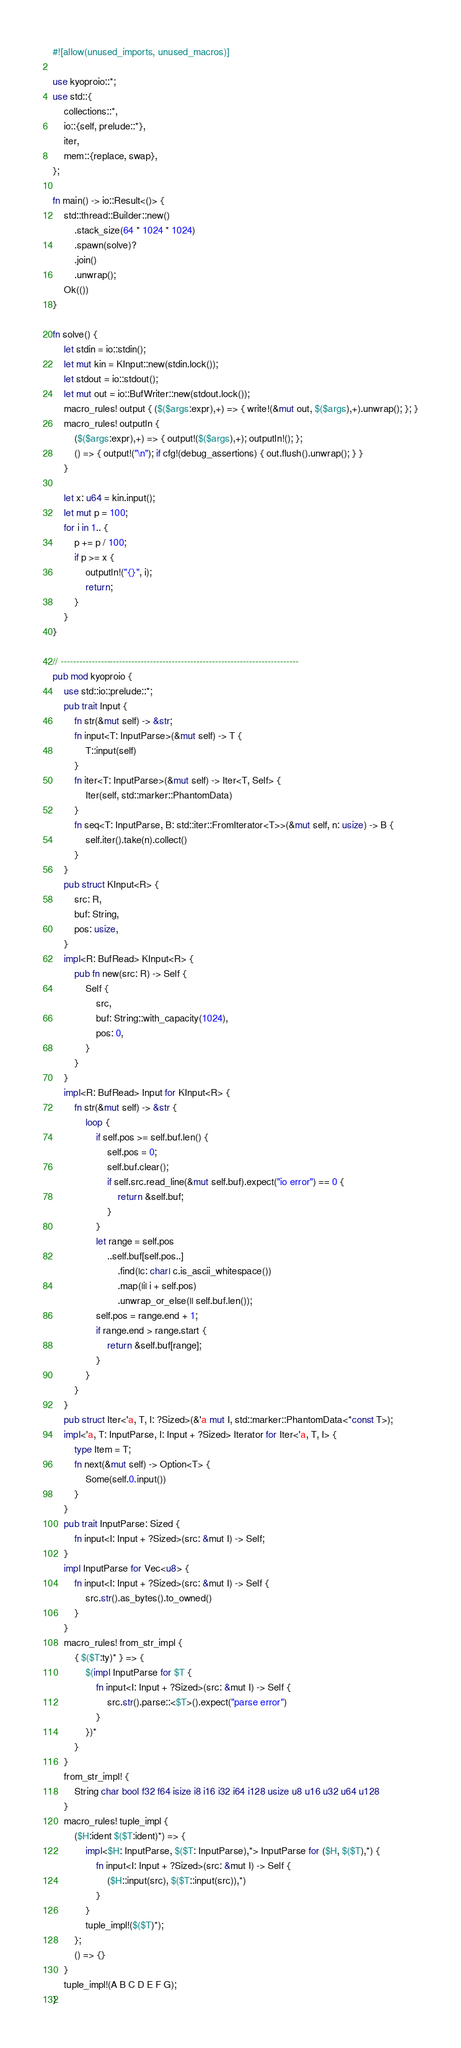Convert code to text. <code><loc_0><loc_0><loc_500><loc_500><_Rust_>#![allow(unused_imports, unused_macros)]

use kyoproio::*;
use std::{
    collections::*,
    io::{self, prelude::*},
    iter,
    mem::{replace, swap},
};

fn main() -> io::Result<()> {
    std::thread::Builder::new()
        .stack_size(64 * 1024 * 1024)
        .spawn(solve)?
        .join()
        .unwrap();
    Ok(())
}

fn solve() {
    let stdin = io::stdin();
    let mut kin = KInput::new(stdin.lock());
    let stdout = io::stdout();
    let mut out = io::BufWriter::new(stdout.lock());
    macro_rules! output { ($($args:expr),+) => { write!(&mut out, $($args),+).unwrap(); }; }
    macro_rules! outputln {
        ($($args:expr),+) => { output!($($args),+); outputln!(); };
        () => { output!("\n"); if cfg!(debug_assertions) { out.flush().unwrap(); } }
    }

    let x: u64 = kin.input();
    let mut p = 100;
    for i in 1.. {
        p += p / 100;
        if p >= x {
            outputln!("{}", i);
            return;
        }
    }
}

// -----------------------------------------------------------------------------
pub mod kyoproio {
    use std::io::prelude::*;
    pub trait Input {
        fn str(&mut self) -> &str;
        fn input<T: InputParse>(&mut self) -> T {
            T::input(self)
        }
        fn iter<T: InputParse>(&mut self) -> Iter<T, Self> {
            Iter(self, std::marker::PhantomData)
        }
        fn seq<T: InputParse, B: std::iter::FromIterator<T>>(&mut self, n: usize) -> B {
            self.iter().take(n).collect()
        }
    }
    pub struct KInput<R> {
        src: R,
        buf: String,
        pos: usize,
    }
    impl<R: BufRead> KInput<R> {
        pub fn new(src: R) -> Self {
            Self {
                src,
                buf: String::with_capacity(1024),
                pos: 0,
            }
        }
    }
    impl<R: BufRead> Input for KInput<R> {
        fn str(&mut self) -> &str {
            loop {
                if self.pos >= self.buf.len() {
                    self.pos = 0;
                    self.buf.clear();
                    if self.src.read_line(&mut self.buf).expect("io error") == 0 {
                        return &self.buf;
                    }
                }
                let range = self.pos
                    ..self.buf[self.pos..]
                        .find(|c: char| c.is_ascii_whitespace())
                        .map(|i| i + self.pos)
                        .unwrap_or_else(|| self.buf.len());
                self.pos = range.end + 1;
                if range.end > range.start {
                    return &self.buf[range];
                }
            }
        }
    }
    pub struct Iter<'a, T, I: ?Sized>(&'a mut I, std::marker::PhantomData<*const T>);
    impl<'a, T: InputParse, I: Input + ?Sized> Iterator for Iter<'a, T, I> {
        type Item = T;
        fn next(&mut self) -> Option<T> {
            Some(self.0.input())
        }
    }
    pub trait InputParse: Sized {
        fn input<I: Input + ?Sized>(src: &mut I) -> Self;
    }
    impl InputParse for Vec<u8> {
        fn input<I: Input + ?Sized>(src: &mut I) -> Self {
            src.str().as_bytes().to_owned()
        }
    }
    macro_rules! from_str_impl {
        { $($T:ty)* } => {
            $(impl InputParse for $T {
                fn input<I: Input + ?Sized>(src: &mut I) -> Self {
                    src.str().parse::<$T>().expect("parse error")
                }
            })*
        }
    }
    from_str_impl! {
        String char bool f32 f64 isize i8 i16 i32 i64 i128 usize u8 u16 u32 u64 u128
    }
    macro_rules! tuple_impl {
        ($H:ident $($T:ident)*) => {
            impl<$H: InputParse, $($T: InputParse),*> InputParse for ($H, $($T),*) {
                fn input<I: Input + ?Sized>(src: &mut I) -> Self {
                    ($H::input(src), $($T::input(src)),*)
                }
            }
            tuple_impl!($($T)*);
        };
        () => {}
    }
    tuple_impl!(A B C D E F G);
}
</code> 